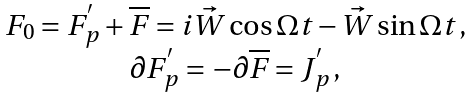<formula> <loc_0><loc_0><loc_500><loc_500>\begin{array} { c } F _ { 0 } = F _ { p } ^ { ^ { \prime } } + \overline { F } = { i } \vec { W } \cos \Omega t - \vec { W } \sin \Omega t \, , \\ \partial F _ { p } ^ { ^ { \prime } } = - \partial \overline { F } = J _ { p } ^ { ^ { \prime } } \, , \end{array}</formula> 